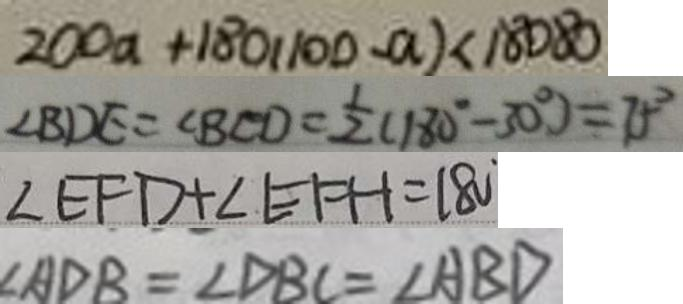<formula> <loc_0><loc_0><loc_500><loc_500>2 0 0 a + 1 8 0 ( 1 0 0 - a ) < 1 8 0 8 0 
 \angle B D E = \angle B C D = \frac { 1 } { 2 } ( 1 8 0 ^ { \circ } - 3 0 ^ { \circ } ) = 7 5 ^ { \circ } 
 \angle E F D + \angle E F H = 1 8 0 
 \angle A D B = \angle D B C = \angle A B D</formula> 